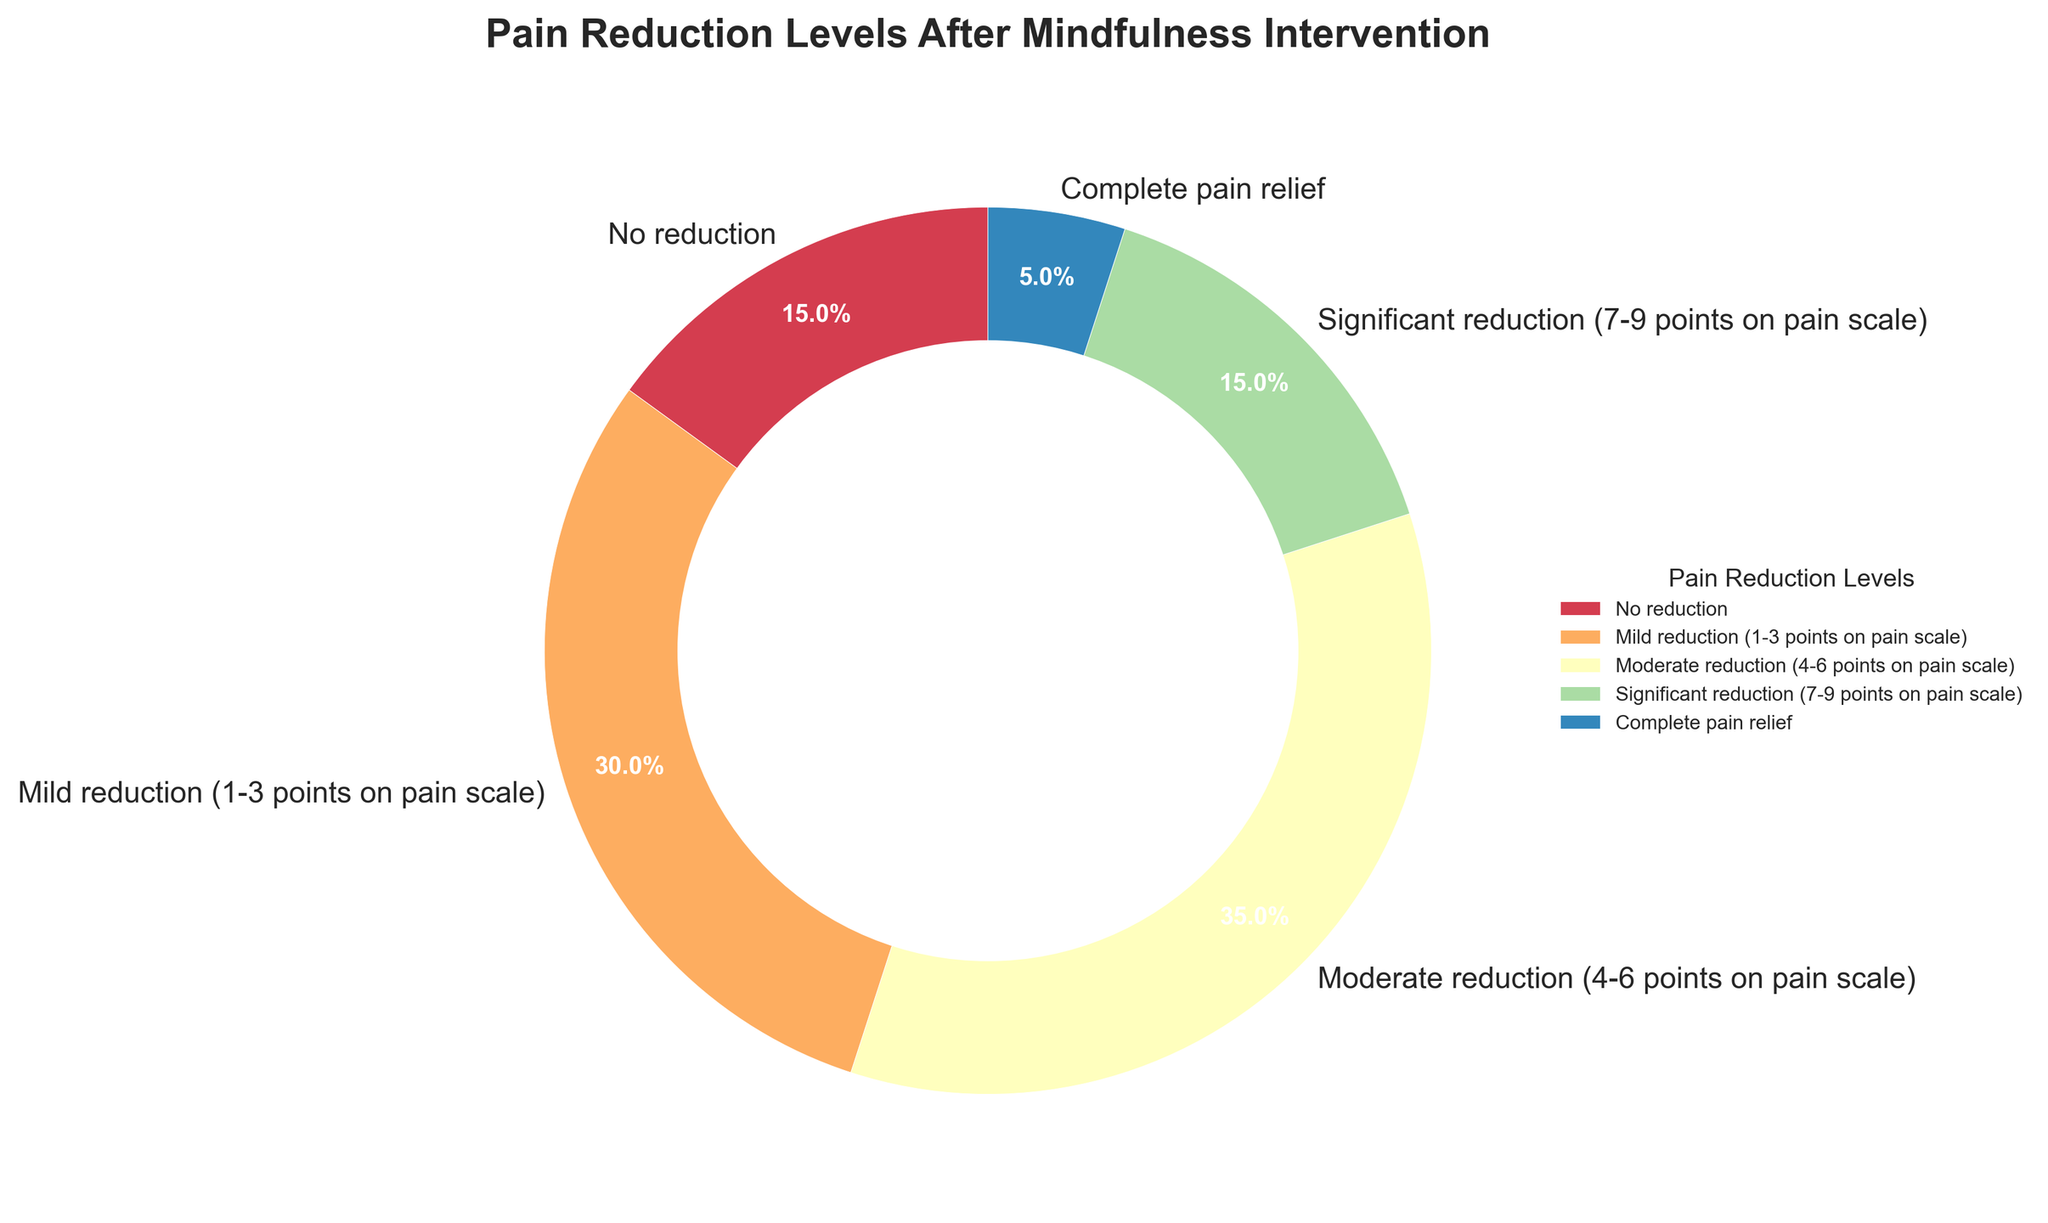What percentage of patients reported mild reduction in pain? The section labeled "Mild reduction (1-3 points on pain scale)" is shown in the pie chart. By looking at the percentage value within this segment, we find it is 30%.
Answer: 30% Which pain reduction level has the highest proportion of patients? Analyze the segments in the pie chart to determine which one has the largest area. The "Moderate reduction (4-6 points on pain scale)" segment appears to be the largest.
Answer: Moderate reduction (4-6 points on pain scale) What is the combined percentage of patients experiencing moderate or significant reduction in pain? Identify the percentages for "Moderate reduction (4-6 points on pain scale)" and "Significant reduction (7-9 points on pain scale)" from the pie chart, which are 35% and 15%, respectively. Summing these values, 35% + 15% = 50%.
Answer: 50% Which pain reduction levels together account for the majority (over 50%) of patients? Total the percentages of various pain reduction levels starting from the largest and continue until the sum exceeds 50%. The percentages for moderate reduction (35%) and mild reduction (30%) add up to 65%, which is over 50%.
Answer: Mild and Moderate reduction How does the proportion of patients with no pain relief compare to those with complete pain relief? Look at the pie chart sections for "No reduction" (15%) and "Complete pain relief" (5%). Comparing these values, more patients reported no reduction in pain than complete pain relief.
Answer: No reduction is greater What proportion of patients reported either no reduction or significant reduction in pain? Sum the percentages for "No reduction" (15%) and "Significant reduction (7-9 points on pain scale)" (15%). Adding these, 15% + 15% = 30%.
Answer: 30% Is the proportion of patients experiencing complete pain relief greater than 10%? Examine the segment in the pie chart for "Complete pain relief." The percentage is 5%, which is less than 10%.
Answer: No What percentage of patients reported a reduction in pain (across all levels)? Sum the percentages of all categories except "No reduction" from the pie chart: 30% (Mild) + 35% (Moderate) + 15% (Significant) + 5% (Complete), which totals 85%.
Answer: 85% Which color represents the moderate reduction level in the pie chart? Refer to the pie chart and identify the segment labeled "Moderate reduction (4-6 points on pain scale)." The color representing this segment can be seen visually on the chart as determined by the chosen color scheme.
Answer: Varied, approximately mid-spectrum in chosen color scheme What can be inferred about the effectiveness of the mindfulness intervention for pain relief based on the pie chart? By looking at the proportion of patients experiencing various levels of pain reduction, a combined 85% reported some degree of pain reduction (mild, moderate, significant, or complete), indicating the intervention had a positive effect for the majority of patients.
Answer: Majority patients experienced pain reduction 